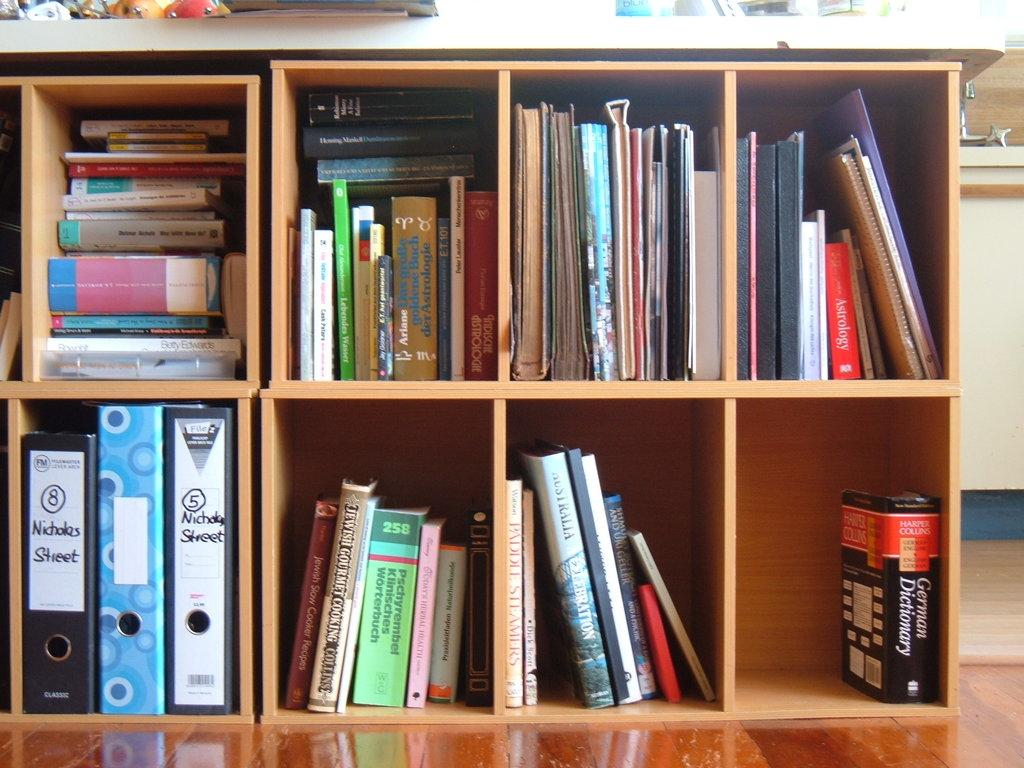What is present on the shelf in the image? There are books and files on the shelf in the image. Can you describe the types of items on the shelf? The items on the shelf are books and files. How many kittens are sitting on the shelf in the image? There are no kittens present on the shelf in the image. What type of mist can be seen surrounding the shelf in the image? There is no mist present around the shelf in the image. 